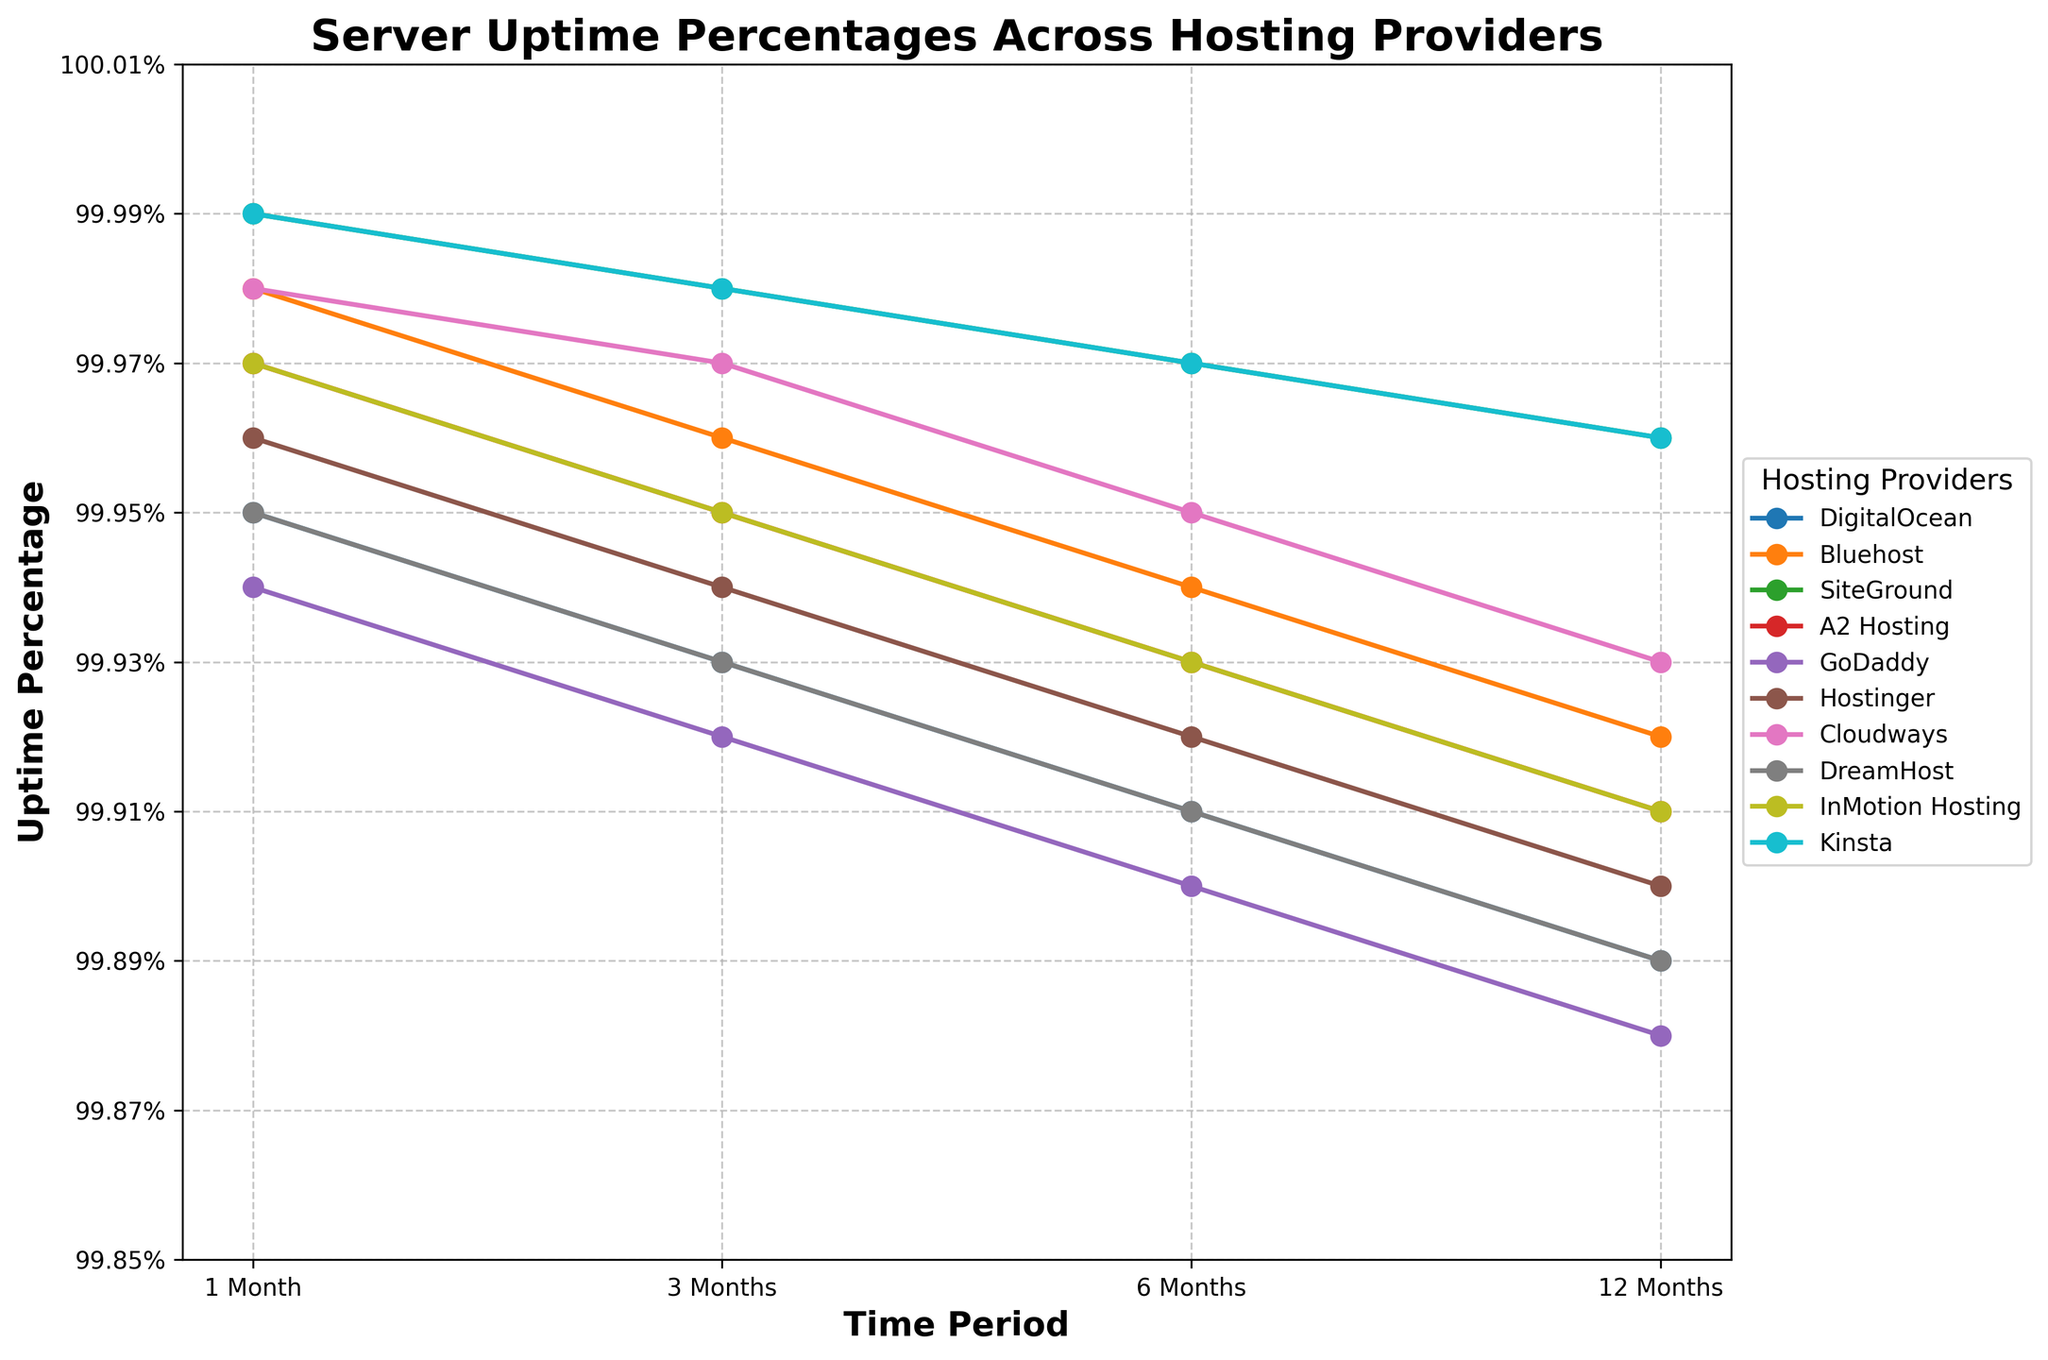Which hosting provider has the highest uptime percentage consistently across all time periods? By examining the lines on the chart, note which provider's line remains consistently the highest across all time periods (1 Month, 3 Months, 6 Months, 12 Months). Kinsta's line remains at the top across all periods.
Answer: Kinsta How much does DigitalOcean's uptime percentage drop from 1 month to 12 months? To find the difference, look at DigitalOcean's uptime percentage at 1 month (99.95%) and at 12 months (99.89%). The drop is calculated as 99.95% - 99.89% = 0.06%.
Answer: 0.06% Which two hosting providers have the most similar uptime percentages over the 6-month period? Observe the chart and compare the 6-month marks for all providers. Hosting providers DigitalOcean and DreamHost both have uptime percentages of 99.91% at 6 months.
Answer: DigitalOcean and DreamHost Which provider shows the greatest improvement in uptime percentage from 1 month to 3 months? To find the greatest improvement, calculate the difference between the 1-month and 3-month uptime percentages for each provider, and identify the maximum. For each provider: DigitalOcean (99.93%-99.95%), Bluehost (99.98%-99.96%), SiteGround (99.98%-99.99%), A2 Hosting (99.95%-99.97%), GoDaddy (99.92%-99.94%), Hostinger (99.94%-99.96%), Cloudways (99.97%-99.98%), DreamHost (99.93%-99.95%), InMotion Hosting (99.95%-99.97%), Kinsta (99.98%-99.99%).
Answer: None (all show a slight decrease or no improvement) Which providers have uptime percentages greater than 99.95% for all periods except the 12-month period? Check which providers consistently have uptime percentages greater than 99.95% for the 1-month, 3-month, and 6-month periods and dip below 99.95% for the 12-month period. Providers that meet this condition: A2 Hosting, Cloudways, InMotion Hosting.
Answer: A2 Hosting, Cloudways, InMotion Hosting What is the average uptime percentage of SiteGround over the 12 months? The uptime percentages for SiteGround are 99.99%, 99.98%, 99.97%, and 99.96%. Calculate the average by summing these and dividing by 4. (99.99 + 99.98 + 99.97 + 99.96) / 4 = 99.975%.
Answer: 99.975% Which hosting provider has the sharpest decline in uptime percentage over the 12-month period? To determine the sharpest decline, subtract the 12-month percentage from the 1-month percentage for each provider and identify the maximum difference. GoDaddy: 99.94% - 99.88% = 0.06%, DigitalOcean: 99.95% - 99.89% = 0.06%, Bluehost: 99.98% - 99.92% = 0.06%, SiteGround: 99.99% - 99.96% = 0.03%, A2 Hosting: 99.97% - 99.91% = 0.06%, Hostinger: 99.96% - 99.90% = 0.06%, Cloudways: 99.98% - 99.93% = 0.05%, DreamHost: 99.95% - 99.89% = 0.06%, InMotion Hosting: 99.97% - 99.91% = 0.06%, Kinsta: 99.99% - 99.96% = 0.03%. Multiple providers show a decline of 0.06%, which is the sharpest drop.
Answer: GoDaddy, DigitalOcean, Bluehost, A2 Hosting, Hostinger, DreamHost, InMotion Hosting Which hosting providers have uptime percentages that start high but end below 99.93% over the 12-month period? Compare the starting (1-month) and ending (12-month) uptime percentages and find those whose 1-month uptime is above 99.93% but drop below 99.93% at 12 months. Providers falling into this category are GoDaddy and Hostinger.
Answer: GoDaddy and Hostinger 